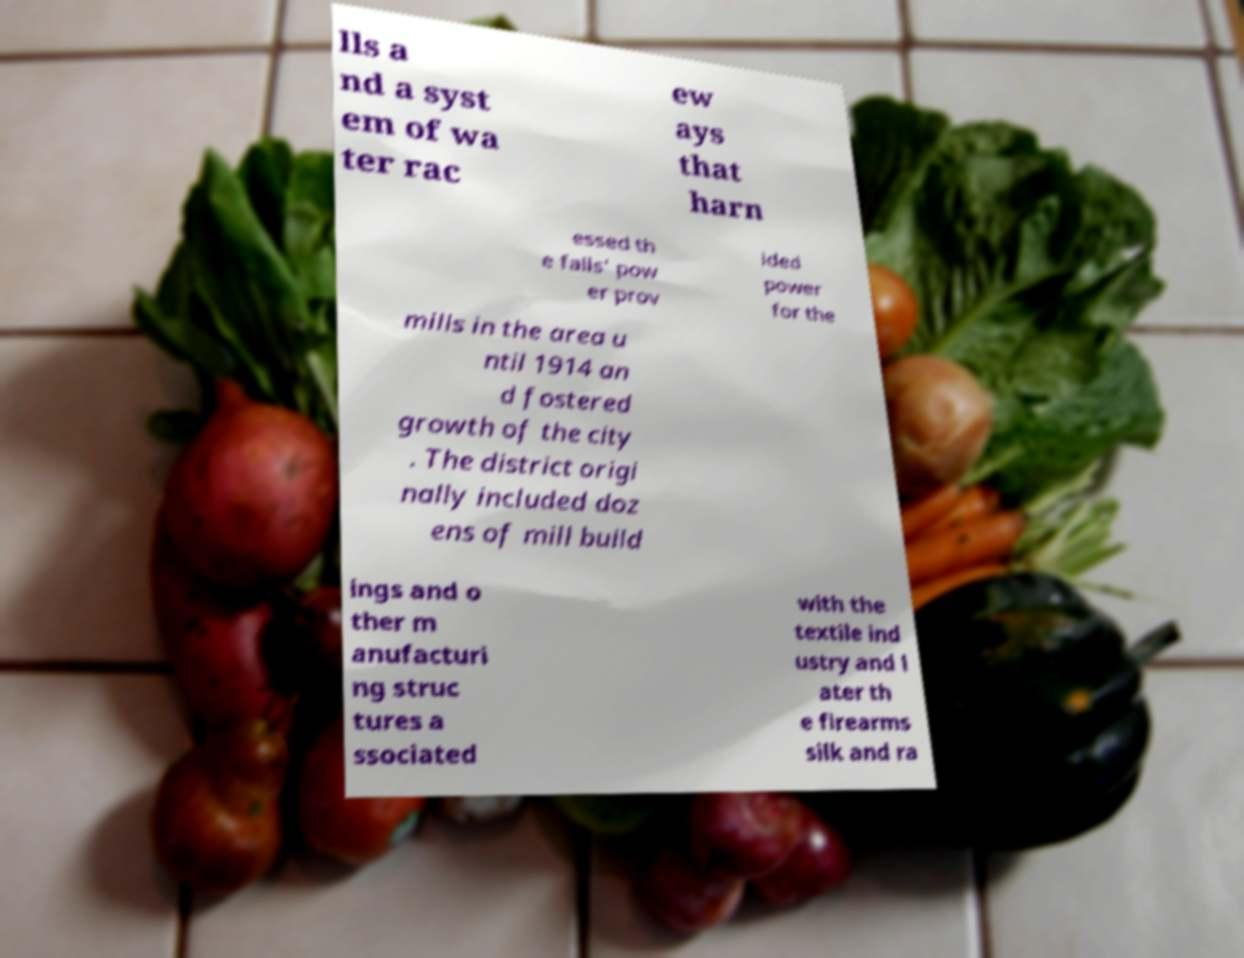What messages or text are displayed in this image? I need them in a readable, typed format. lls a nd a syst em of wa ter rac ew ays that harn essed th e falls' pow er prov ided power for the mills in the area u ntil 1914 an d fostered growth of the city . The district origi nally included doz ens of mill build ings and o ther m anufacturi ng struc tures a ssociated with the textile ind ustry and l ater th e firearms silk and ra 